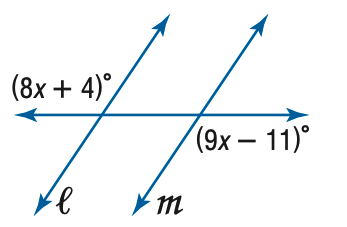Question: Find x so that m \parallel n.
Choices:
A. 7
B. 9
C. 11
D. 15
Answer with the letter. Answer: D 